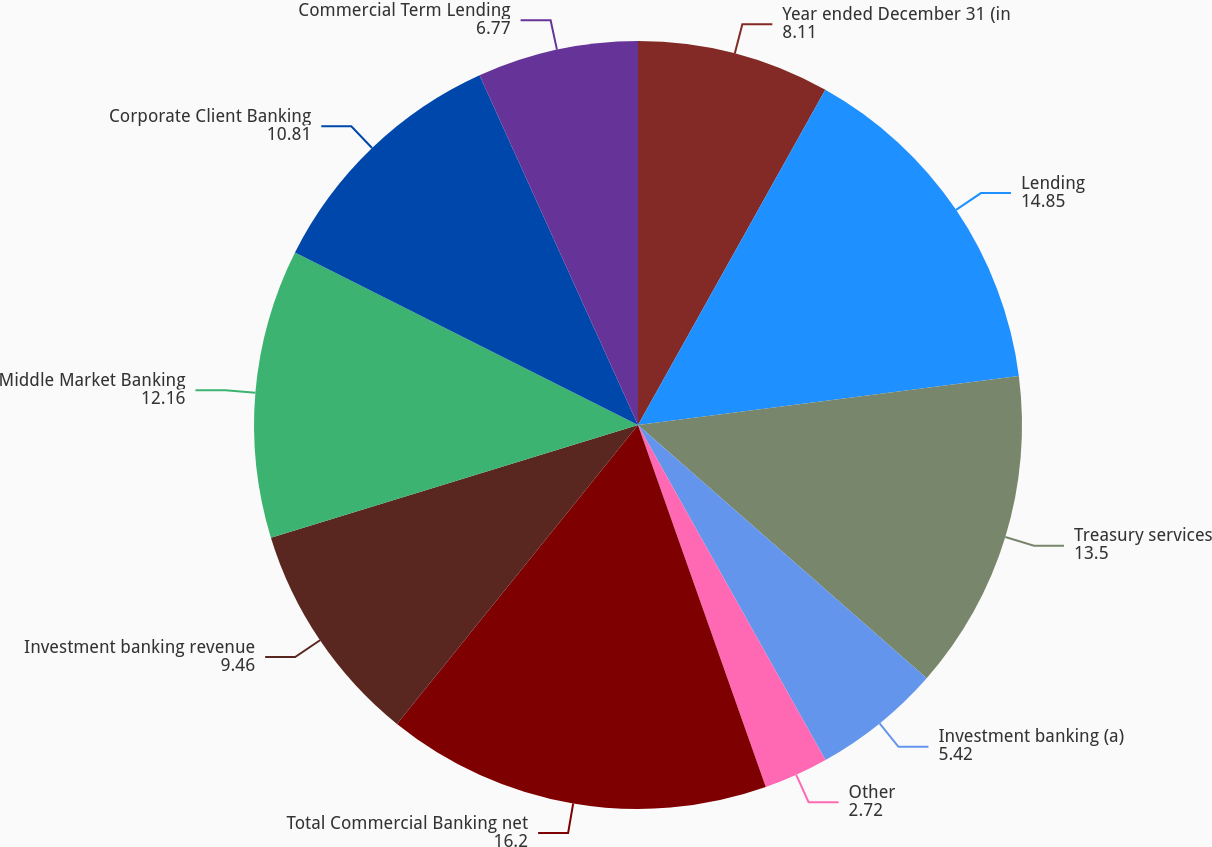Convert chart. <chart><loc_0><loc_0><loc_500><loc_500><pie_chart><fcel>Year ended December 31 (in<fcel>Lending<fcel>Treasury services<fcel>Investment banking (a)<fcel>Other<fcel>Total Commercial Banking net<fcel>Investment banking revenue<fcel>Middle Market Banking<fcel>Corporate Client Banking<fcel>Commercial Term Lending<nl><fcel>8.11%<fcel>14.85%<fcel>13.5%<fcel>5.42%<fcel>2.72%<fcel>16.2%<fcel>9.46%<fcel>12.16%<fcel>10.81%<fcel>6.77%<nl></chart> 